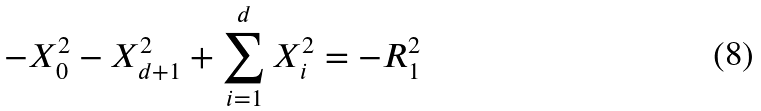<formula> <loc_0><loc_0><loc_500><loc_500>- X _ { 0 } ^ { 2 } - X _ { d + 1 } ^ { 2 } + \sum _ { i = 1 } ^ { d } X _ { i } ^ { 2 } = - R _ { 1 } ^ { 2 }</formula> 